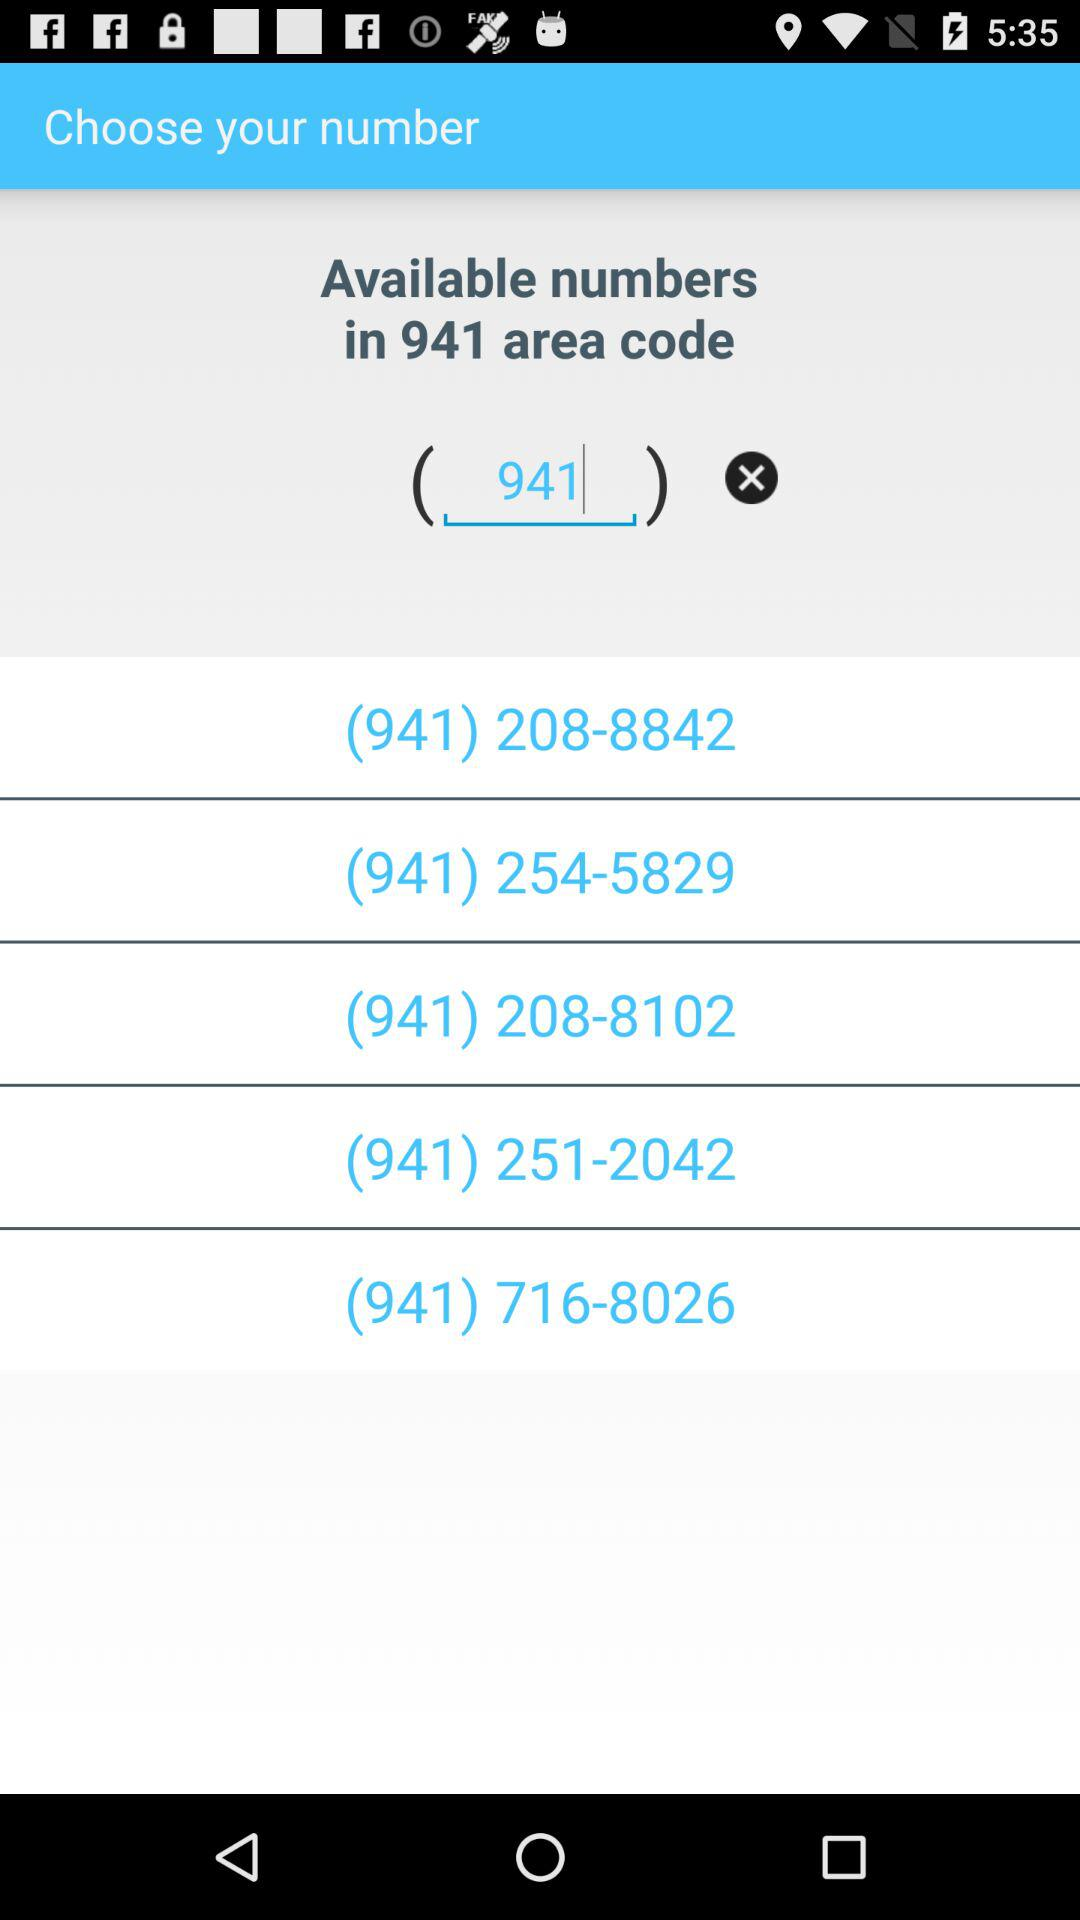What is the entered area code? The entered area code is 941. 